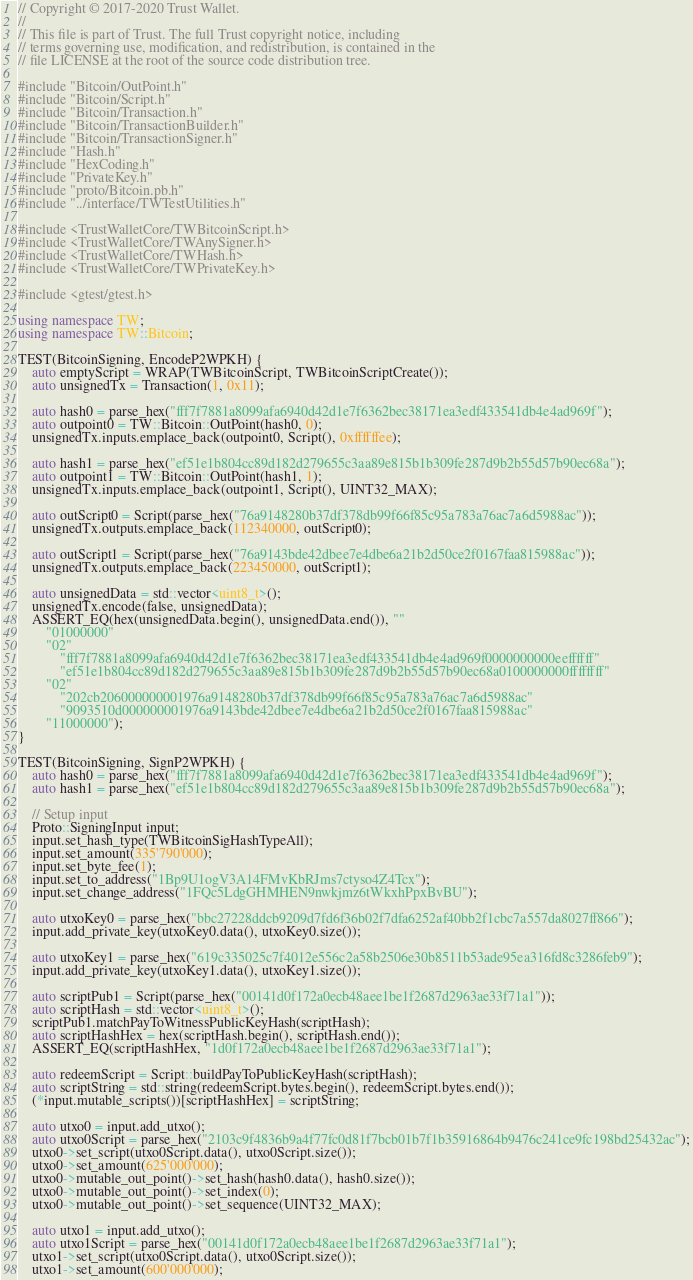Convert code to text. <code><loc_0><loc_0><loc_500><loc_500><_C++_>// Copyright © 2017-2020 Trust Wallet.
//
// This file is part of Trust. The full Trust copyright notice, including
// terms governing use, modification, and redistribution, is contained in the
// file LICENSE at the root of the source code distribution tree.

#include "Bitcoin/OutPoint.h"
#include "Bitcoin/Script.h"
#include "Bitcoin/Transaction.h"
#include "Bitcoin/TransactionBuilder.h"
#include "Bitcoin/TransactionSigner.h"
#include "Hash.h"
#include "HexCoding.h"
#include "PrivateKey.h"
#include "proto/Bitcoin.pb.h"
#include "../interface/TWTestUtilities.h"

#include <TrustWalletCore/TWBitcoinScript.h>
#include <TrustWalletCore/TWAnySigner.h>
#include <TrustWalletCore/TWHash.h>
#include <TrustWalletCore/TWPrivateKey.h>

#include <gtest/gtest.h>

using namespace TW;
using namespace TW::Bitcoin;

TEST(BitcoinSigning, EncodeP2WPKH) {
    auto emptyScript = WRAP(TWBitcoinScript, TWBitcoinScriptCreate());
    auto unsignedTx = Transaction(1, 0x11);

    auto hash0 = parse_hex("fff7f7881a8099afa6940d42d1e7f6362bec38171ea3edf433541db4e4ad969f");
    auto outpoint0 = TW::Bitcoin::OutPoint(hash0, 0);
    unsignedTx.inputs.emplace_back(outpoint0, Script(), 0xffffffee);

    auto hash1 = parse_hex("ef51e1b804cc89d182d279655c3aa89e815b1b309fe287d9b2b55d57b90ec68a");
    auto outpoint1 = TW::Bitcoin::OutPoint(hash1, 1);
    unsignedTx.inputs.emplace_back(outpoint1, Script(), UINT32_MAX);

    auto outScript0 = Script(parse_hex("76a9148280b37df378db99f66f85c95a783a76ac7a6d5988ac"));
    unsignedTx.outputs.emplace_back(112340000, outScript0);

    auto outScript1 = Script(parse_hex("76a9143bde42dbee7e4dbe6a21b2d50ce2f0167faa815988ac"));
    unsignedTx.outputs.emplace_back(223450000, outScript1);

    auto unsignedData = std::vector<uint8_t>();
    unsignedTx.encode(false, unsignedData);
    ASSERT_EQ(hex(unsignedData.begin(), unsignedData.end()), ""
        "01000000"
        "02"
            "fff7f7881a8099afa6940d42d1e7f6362bec38171ea3edf433541db4e4ad969f0000000000eeffffff"
            "ef51e1b804cc89d182d279655c3aa89e815b1b309fe287d9b2b55d57b90ec68a0100000000ffffffff"
        "02"
            "202cb206000000001976a9148280b37df378db99f66f85c95a783a76ac7a6d5988ac"
            "9093510d000000001976a9143bde42dbee7e4dbe6a21b2d50ce2f0167faa815988ac"
        "11000000");
}

TEST(BitcoinSigning, SignP2WPKH) {
    auto hash0 = parse_hex("fff7f7881a8099afa6940d42d1e7f6362bec38171ea3edf433541db4e4ad969f");
    auto hash1 = parse_hex("ef51e1b804cc89d182d279655c3aa89e815b1b309fe287d9b2b55d57b90ec68a");

    // Setup input
    Proto::SigningInput input;
    input.set_hash_type(TWBitcoinSigHashTypeAll);
    input.set_amount(335'790'000);
    input.set_byte_fee(1);
    input.set_to_address("1Bp9U1ogV3A14FMvKbRJms7ctyso4Z4Tcx");
    input.set_change_address("1FQc5LdgGHMHEN9nwkjmz6tWkxhPpxBvBU");

    auto utxoKey0 = parse_hex("bbc27228ddcb9209d7fd6f36b02f7dfa6252af40bb2f1cbc7a557da8027ff866");
    input.add_private_key(utxoKey0.data(), utxoKey0.size());

    auto utxoKey1 = parse_hex("619c335025c7f4012e556c2a58b2506e30b8511b53ade95ea316fd8c3286feb9");
    input.add_private_key(utxoKey1.data(), utxoKey1.size());

    auto scriptPub1 = Script(parse_hex("00141d0f172a0ecb48aee1be1f2687d2963ae33f71a1"));
    auto scriptHash = std::vector<uint8_t>();
    scriptPub1.matchPayToWitnessPublicKeyHash(scriptHash);
    auto scriptHashHex = hex(scriptHash.begin(), scriptHash.end());
    ASSERT_EQ(scriptHashHex, "1d0f172a0ecb48aee1be1f2687d2963ae33f71a1");

    auto redeemScript = Script::buildPayToPublicKeyHash(scriptHash);
    auto scriptString = std::string(redeemScript.bytes.begin(), redeemScript.bytes.end());
    (*input.mutable_scripts())[scriptHashHex] = scriptString;

    auto utxo0 = input.add_utxo();
    auto utxo0Script = parse_hex("2103c9f4836b9a4f77fc0d81f7bcb01b7f1b35916864b9476c241ce9fc198bd25432ac");
    utxo0->set_script(utxo0Script.data(), utxo0Script.size());
    utxo0->set_amount(625'000'000);
    utxo0->mutable_out_point()->set_hash(hash0.data(), hash0.size());
    utxo0->mutable_out_point()->set_index(0);
    utxo0->mutable_out_point()->set_sequence(UINT32_MAX);

    auto utxo1 = input.add_utxo();
    auto utxo1Script = parse_hex("00141d0f172a0ecb48aee1be1f2687d2963ae33f71a1");
    utxo1->set_script(utxo0Script.data(), utxo0Script.size());
    utxo1->set_amount(600'000'000);</code> 